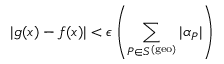<formula> <loc_0><loc_0><loc_500><loc_500>| g ( x ) - f ( x ) | < \epsilon \left ( \sum _ { P \in S ^ { ( g e o ) } } | \alpha _ { P } | \right )</formula> 